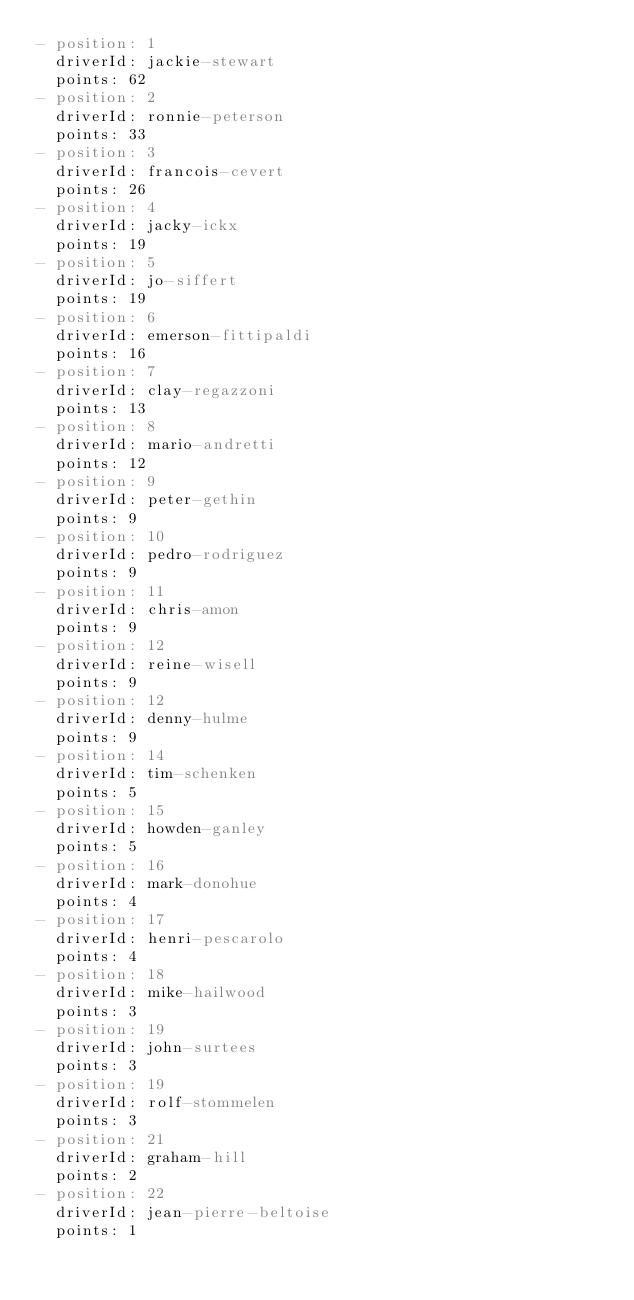<code> <loc_0><loc_0><loc_500><loc_500><_YAML_>- position: 1
  driverId: jackie-stewart
  points: 62
- position: 2
  driverId: ronnie-peterson
  points: 33
- position: 3
  driverId: francois-cevert
  points: 26
- position: 4
  driverId: jacky-ickx
  points: 19
- position: 5
  driverId: jo-siffert
  points: 19
- position: 6
  driverId: emerson-fittipaldi
  points: 16
- position: 7
  driverId: clay-regazzoni
  points: 13
- position: 8
  driverId: mario-andretti
  points: 12
- position: 9
  driverId: peter-gethin
  points: 9
- position: 10
  driverId: pedro-rodriguez
  points: 9
- position: 11
  driverId: chris-amon
  points: 9
- position: 12
  driverId: reine-wisell
  points: 9
- position: 12
  driverId: denny-hulme
  points: 9
- position: 14
  driverId: tim-schenken
  points: 5
- position: 15
  driverId: howden-ganley
  points: 5
- position: 16
  driverId: mark-donohue
  points: 4
- position: 17
  driverId: henri-pescarolo
  points: 4
- position: 18
  driverId: mike-hailwood
  points: 3
- position: 19
  driverId: john-surtees
  points: 3
- position: 19
  driverId: rolf-stommelen
  points: 3
- position: 21
  driverId: graham-hill
  points: 2
- position: 22
  driverId: jean-pierre-beltoise
  points: 1
</code> 